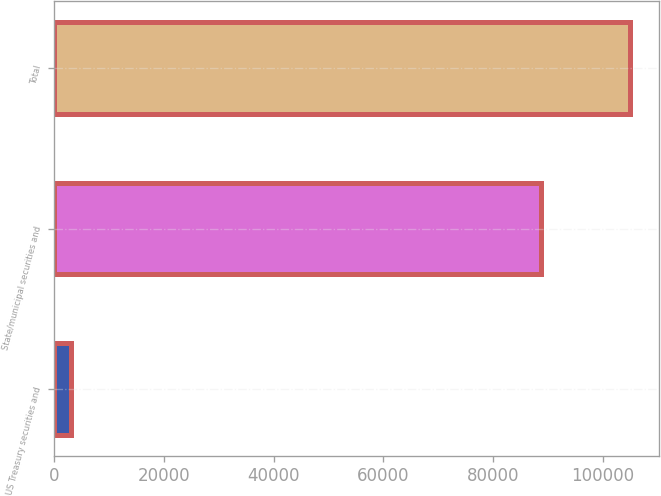Convert chart to OTSL. <chart><loc_0><loc_0><loc_500><loc_500><bar_chart><fcel>US Treasury securities and<fcel>State/municipal securities and<fcel>Total<nl><fcel>2998<fcel>88723<fcel>104999<nl></chart> 